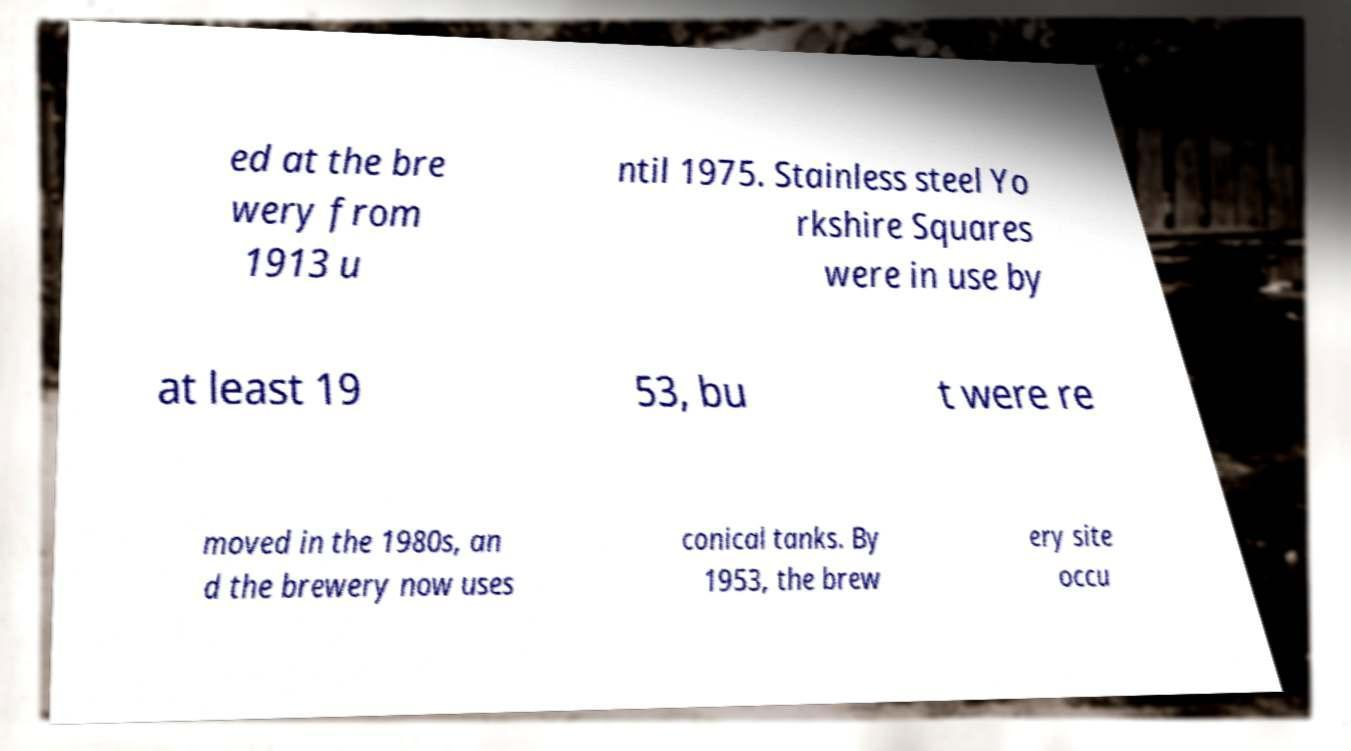What messages or text are displayed in this image? I need them in a readable, typed format. ed at the bre wery from 1913 u ntil 1975. Stainless steel Yo rkshire Squares were in use by at least 19 53, bu t were re moved in the 1980s, an d the brewery now uses conical tanks. By 1953, the brew ery site occu 